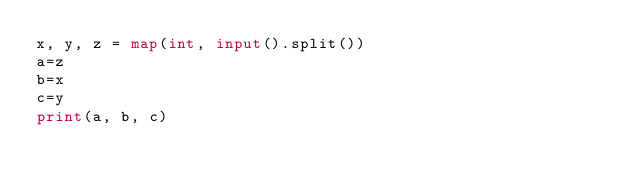<code> <loc_0><loc_0><loc_500><loc_500><_Python_>x, y, z = map(int, input().split())
a=z
b=x
c=y
print(a, b, c)</code> 